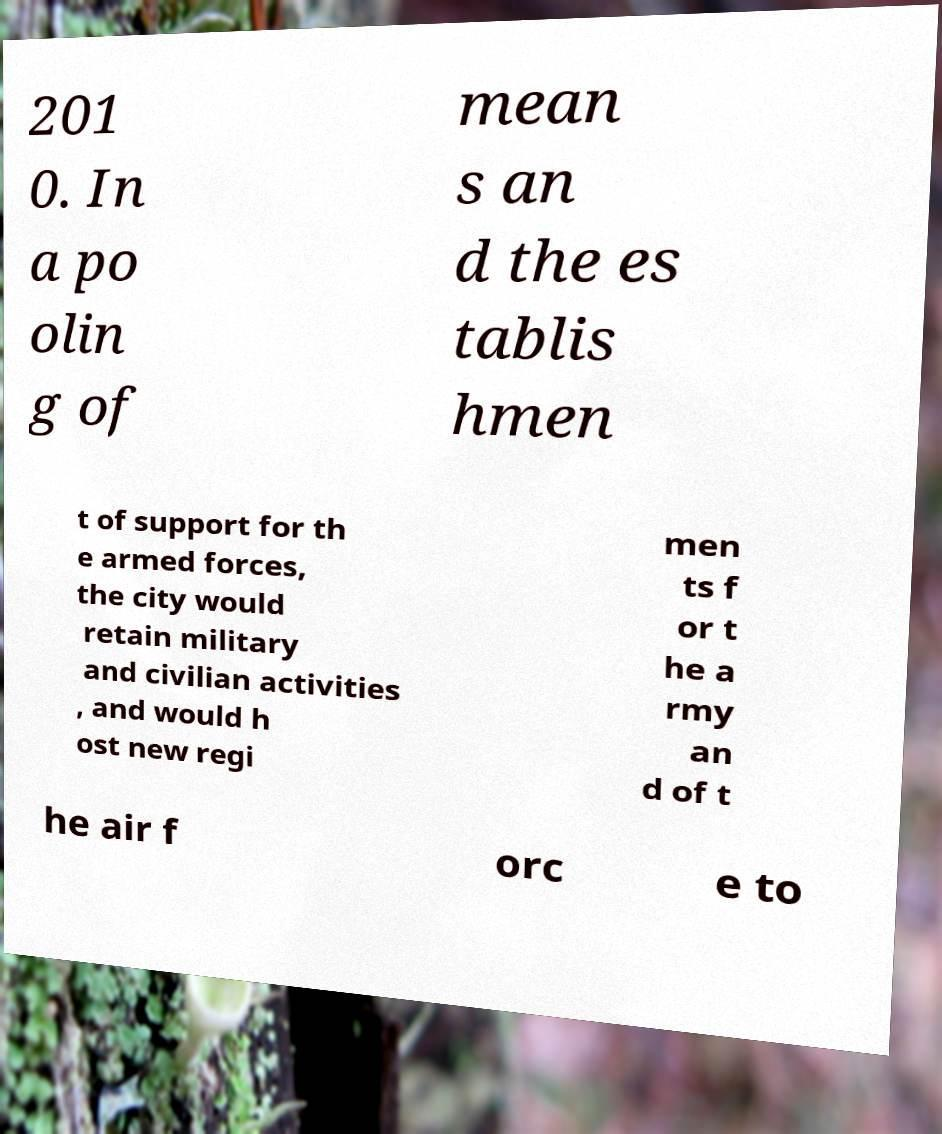Please read and relay the text visible in this image. What does it say? 201 0. In a po olin g of mean s an d the es tablis hmen t of support for th e armed forces, the city would retain military and civilian activities , and would h ost new regi men ts f or t he a rmy an d of t he air f orc e to 